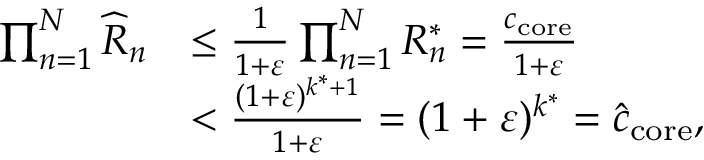<formula> <loc_0><loc_0><loc_500><loc_500>\begin{array} { r l } { \prod _ { n = 1 } ^ { N } \widehat { R } _ { n } } & { \leq \frac { 1 } { 1 + \varepsilon } \prod _ { n = 1 } ^ { N } R _ { n } ^ { * } = \frac { c _ { c o r e } } { 1 + \varepsilon } } \\ & { < \frac { ( 1 + \varepsilon ) ^ { k ^ { * } + 1 } } { 1 + \varepsilon } = ( 1 + \varepsilon ) ^ { k ^ { * } } = \widehat { c } _ { c o r e } , } \end{array}</formula> 